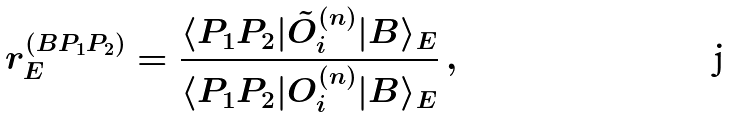<formula> <loc_0><loc_0><loc_500><loc_500>r ^ { ( B P _ { 1 } P _ { 2 } ) } _ { E } = \frac { \langle P _ { 1 } P _ { 2 } | \tilde { O } _ { i } ^ { ( n ) } | B \rangle _ { E } } { \langle P _ { 1 } P _ { 2 } | O _ { i } ^ { ( n ) } | B \rangle _ { E } } \, ,</formula> 